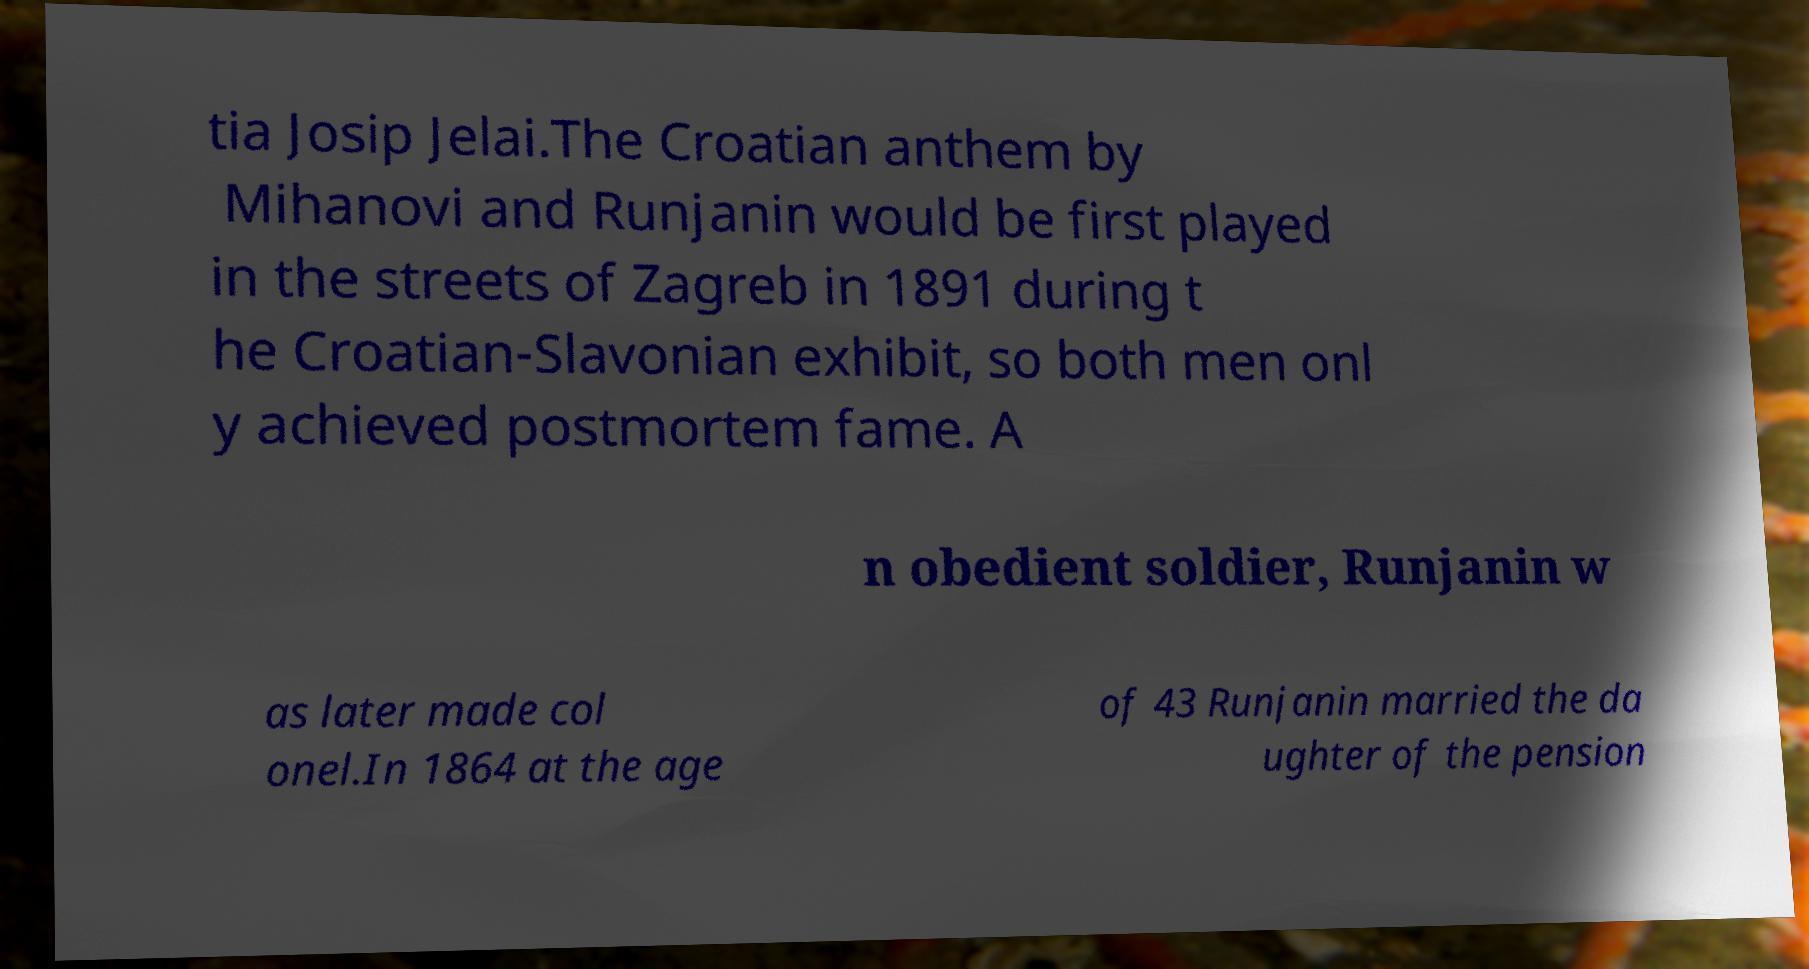Could you extract and type out the text from this image? tia Josip Jelai.The Croatian anthem by Mihanovi and Runjanin would be first played in the streets of Zagreb in 1891 during t he Croatian-Slavonian exhibit, so both men onl y achieved postmortem fame. A n obedient soldier, Runjanin w as later made col onel.In 1864 at the age of 43 Runjanin married the da ughter of the pension 